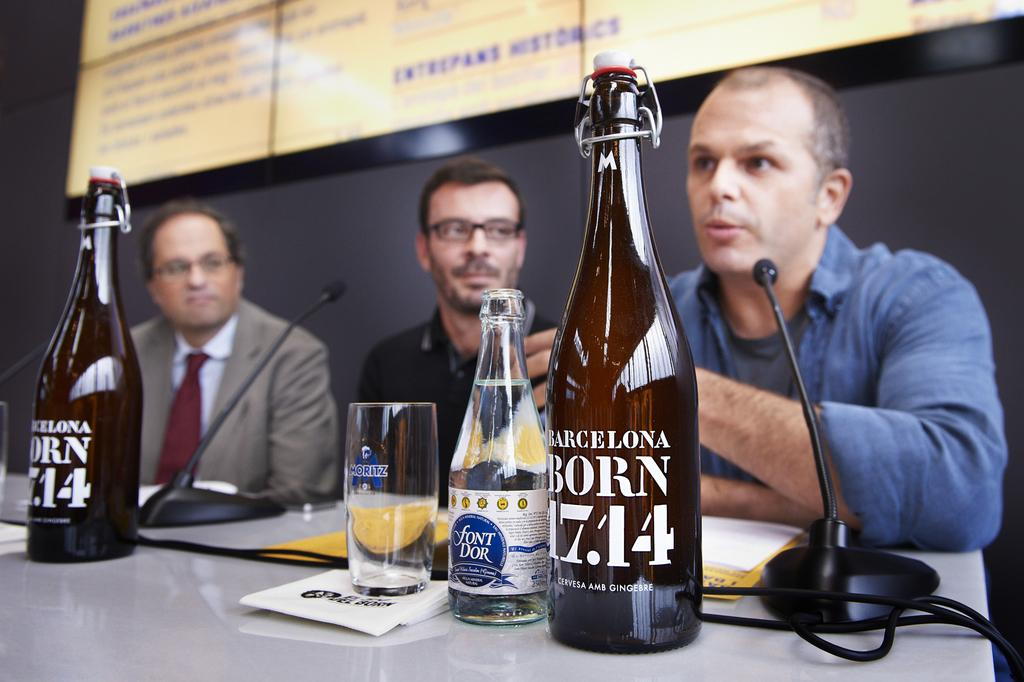Provide a one-sentence caption for the provided image. Three men speaking on a panel with bottles in front of them that read "Barcelona Born 17.14" and "Font Dor". 